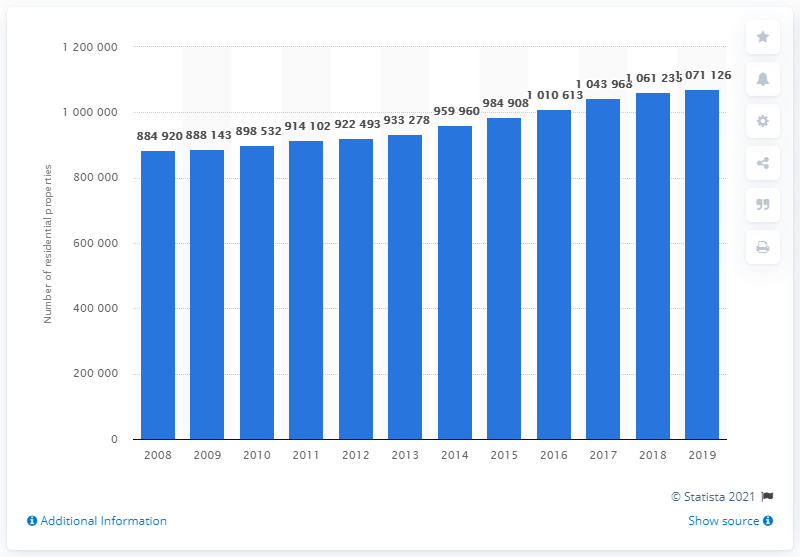Point out several critical features in this image. In 2019, a total of 107,112 residential properties were under the management of the Housing and Development Board (HDB). 